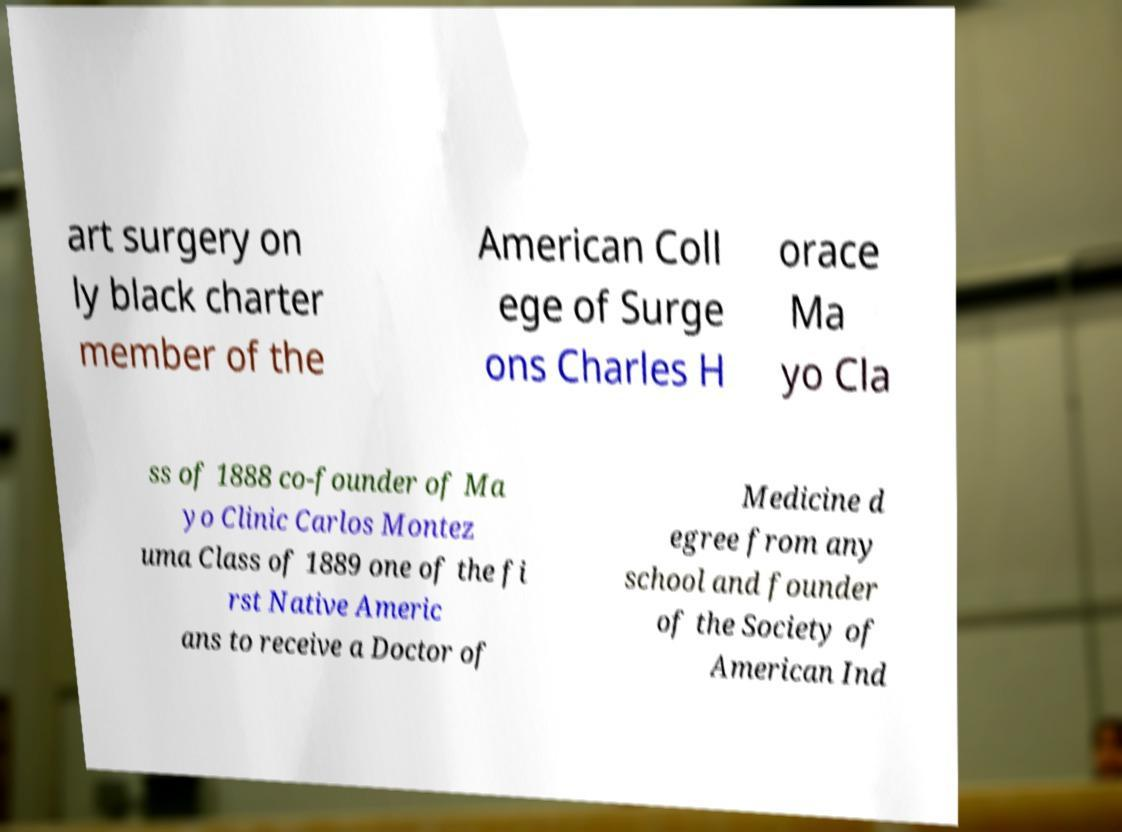What messages or text are displayed in this image? I need them in a readable, typed format. art surgery on ly black charter member of the American Coll ege of Surge ons Charles H orace Ma yo Cla ss of 1888 co-founder of Ma yo Clinic Carlos Montez uma Class of 1889 one of the fi rst Native Americ ans to receive a Doctor of Medicine d egree from any school and founder of the Society of American Ind 